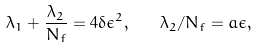<formula> <loc_0><loc_0><loc_500><loc_500>\lambda _ { 1 } + \frac { \lambda _ { 2 } } { N _ { f } } = 4 \delta \epsilon ^ { 2 } , \quad \lambda _ { 2 } / N _ { f } = a \epsilon ,</formula> 